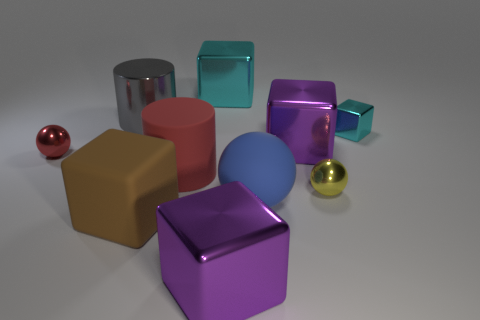Are there any green spheres made of the same material as the blue sphere?
Make the answer very short. No. There is another cube that is the same color as the small metal cube; what material is it?
Ensure brevity in your answer.  Metal. Do the big cube that is behind the small cyan shiny block and the cylinder to the left of the big rubber block have the same material?
Give a very brief answer. Yes. Is the number of brown matte objects greater than the number of blue rubber cylinders?
Provide a short and direct response. Yes. What is the color of the big shiny block left of the big purple metallic cube to the left of the purple metallic block behind the large matte cylinder?
Offer a terse response. Cyan. Is the color of the small metal ball behind the yellow metal sphere the same as the large cylinder in front of the red sphere?
Your answer should be very brief. Yes. How many metal balls are to the left of the shiny block behind the gray thing?
Give a very brief answer. 1. Are any big brown matte spheres visible?
Ensure brevity in your answer.  No. What number of other objects are the same color as the rubber block?
Your response must be concise. 0. Are there fewer big cyan things than small rubber cylinders?
Provide a succinct answer. No. 